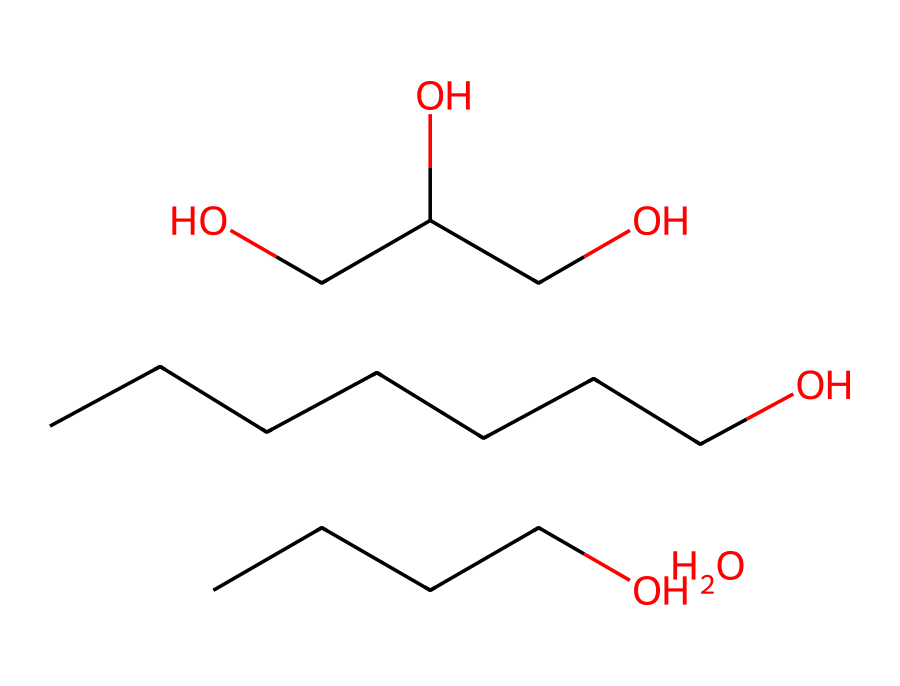What is the primary functional group present in this chemical? The chemical structure indicates the presence of multiple hydroxyl (–OH) groups, which are characteristic of alcohols. The molecular structure reflects significant multiple –OH groups, confirming alcohol as the primary functional group.
Answer: alcohol How many carbon atoms are in this chemical? By analyzing the SMILES representation, we can count the number of carbon atoms connected in the structure. There are 9 carbon atoms clearly represented.
Answer: 9 What is the total number of hydrogen atoms in this chemical? Each carbon generally bonds with hydrogen atoms to satisfy the tetravalency, and by examining the structure, we can deduce the total number of hydrogen atoms bonded to the carbon framework. This chemical has a total of 20 hydrogen atoms.
Answer: 20 What does the presence of multiple –OH groups indicate about the solubility of this chemical? The multiple hydroxyl groups enhance the polar characteristics of the chemical, increasing its solubility in water and indicating that it is likely hydrophilic.
Answer: hydrophilic What is the longest carbon chain present in this chemical? The longest continuous sequence of carbon atoms in the SMILES is analyzed. The longest chain can be traced to contain 7 carbon atoms, reflecting a seven-carbon backbone.
Answer: 7 Does this chemical contain any functional groups other than alcohols? After analyzing the structure, the only functional groups present are hydroxyl groups; no other distinct functional groups such as amines or ketones are recognized within the provided SMILES, confirming that only alcohols are present.
Answer: no 